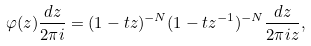Convert formula to latex. <formula><loc_0><loc_0><loc_500><loc_500>\varphi ( z ) \frac { d z } { 2 \pi i } = ( 1 - t z ) ^ { - N } ( 1 - t z ^ { - 1 } ) ^ { - N } \frac { d z } { 2 \pi i z } ,</formula> 